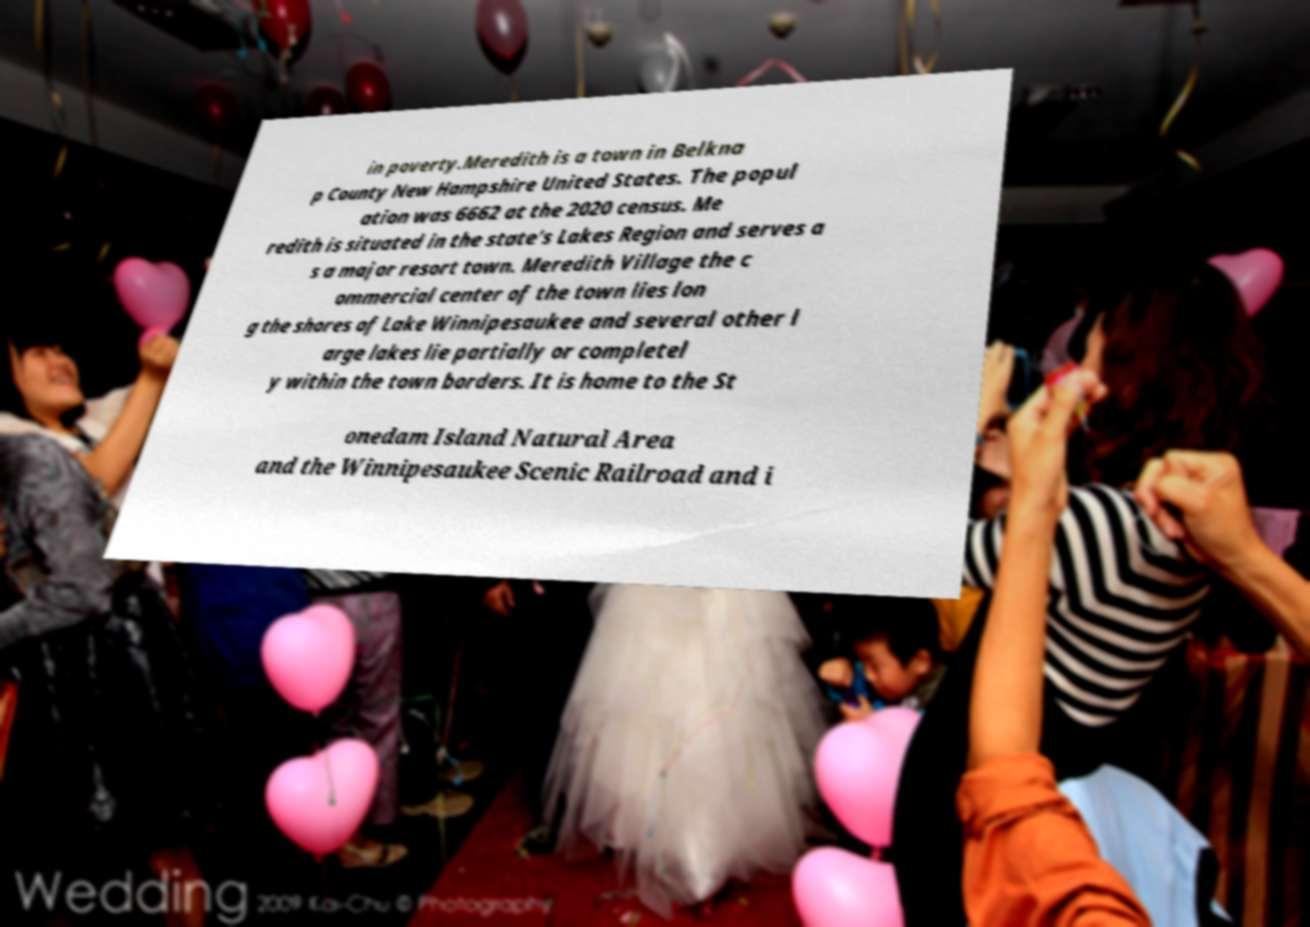For documentation purposes, I need the text within this image transcribed. Could you provide that? in poverty.Meredith is a town in Belkna p County New Hampshire United States. The popul ation was 6662 at the 2020 census. Me redith is situated in the state's Lakes Region and serves a s a major resort town. Meredith Village the c ommercial center of the town lies lon g the shores of Lake Winnipesaukee and several other l arge lakes lie partially or completel y within the town borders. It is home to the St onedam Island Natural Area and the Winnipesaukee Scenic Railroad and i 